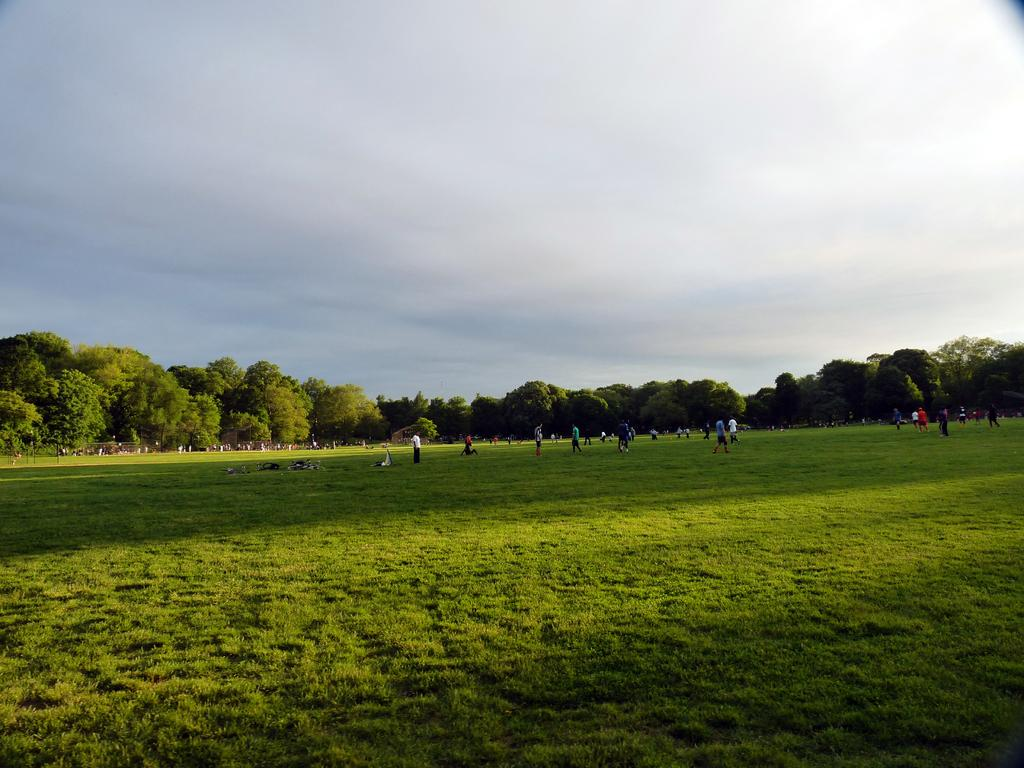What is the primary surface visible in the image? There is a ground in the image. What are the people in the image doing? The people are standing on the ground. What can be seen in the distance behind the people? There are trees in the background of the image. What is visible above the trees in the image? The sky is visible in the background of the image. How many eyes can be seen on the knee in the image? There are no knees or eyes present in the image. 